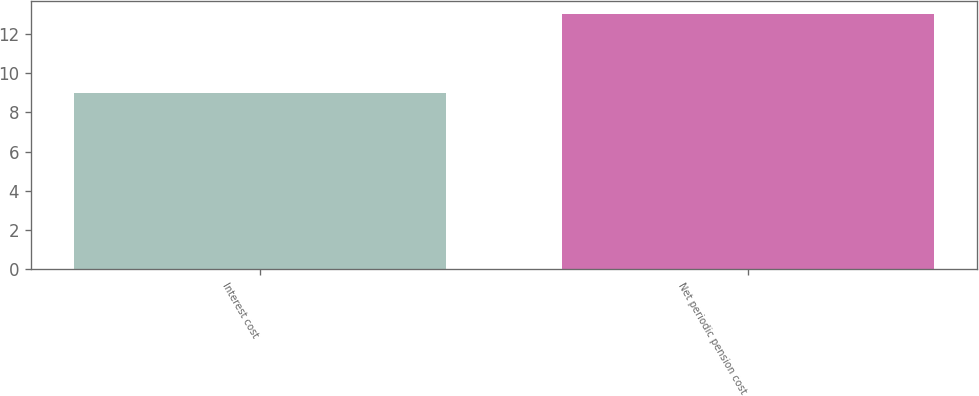<chart> <loc_0><loc_0><loc_500><loc_500><bar_chart><fcel>Interest cost<fcel>Net periodic pension cost<nl><fcel>9<fcel>13<nl></chart> 